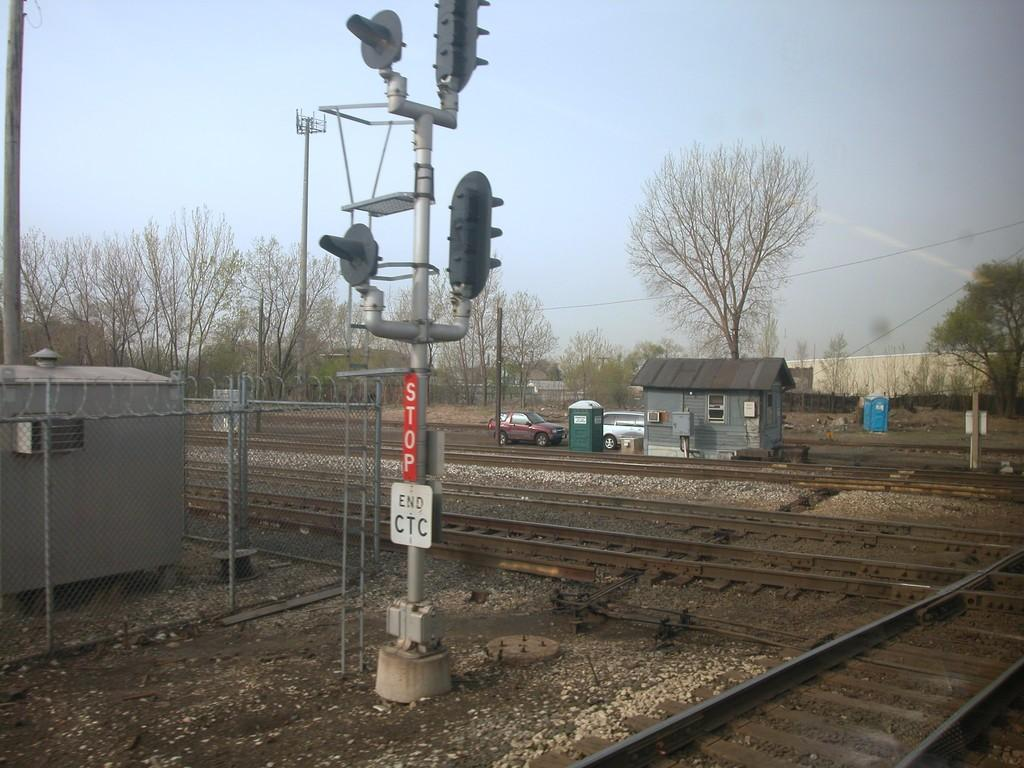What types of structures can be seen in the image? There are vehicles, houses, fencing, railway tracks, and trees visible in the image. What other elements can be seen in the image? Wires, poles, and the sky are also visible in the image. Where is the amusement park located in the image? There is no amusement park present in the image. What type of love can be seen between the trees in the image? There is no representation of love between the trees in the image; they are simply trees. 